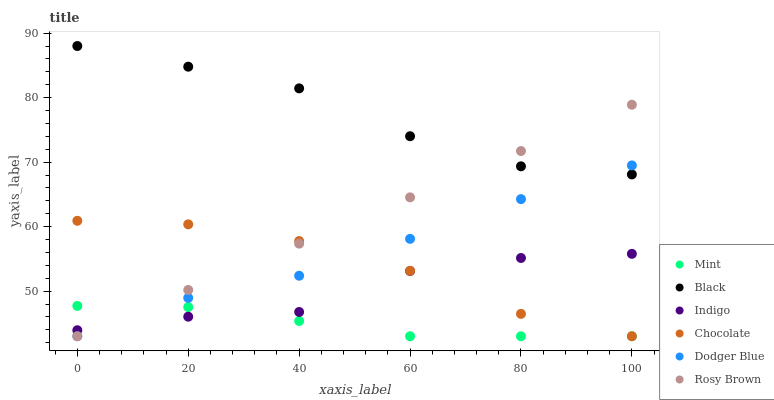Does Mint have the minimum area under the curve?
Answer yes or no. Yes. Does Black have the maximum area under the curve?
Answer yes or no. Yes. Does Rosy Brown have the minimum area under the curve?
Answer yes or no. No. Does Rosy Brown have the maximum area under the curve?
Answer yes or no. No. Is Rosy Brown the smoothest?
Answer yes or no. Yes. Is Indigo the roughest?
Answer yes or no. Yes. Is Chocolate the smoothest?
Answer yes or no. No. Is Chocolate the roughest?
Answer yes or no. No. Does Rosy Brown have the lowest value?
Answer yes or no. Yes. Does Black have the lowest value?
Answer yes or no. No. Does Black have the highest value?
Answer yes or no. Yes. Does Rosy Brown have the highest value?
Answer yes or no. No. Is Indigo less than Black?
Answer yes or no. Yes. Is Black greater than Chocolate?
Answer yes or no. Yes. Does Indigo intersect Rosy Brown?
Answer yes or no. Yes. Is Indigo less than Rosy Brown?
Answer yes or no. No. Is Indigo greater than Rosy Brown?
Answer yes or no. No. Does Indigo intersect Black?
Answer yes or no. No. 